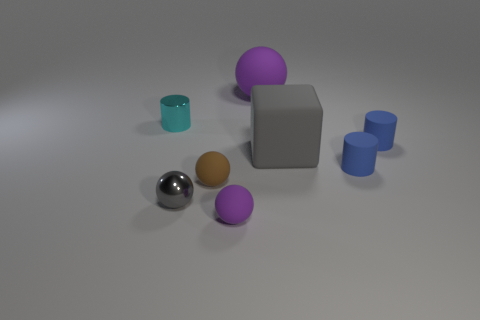Do the small purple thing and the cyan metal object have the same shape?
Ensure brevity in your answer.  No. There is a cylinder that is behind the rubber cylinder behind the gray thing behind the brown rubber object; what is its color?
Keep it short and to the point. Cyan. There is a gray object that is right of the tiny gray thing; what is its shape?
Provide a succinct answer. Cube. What number of things are either gray cubes or cylinders left of the big gray rubber thing?
Provide a succinct answer. 2. Are the cyan cylinder and the gray block made of the same material?
Your response must be concise. No. Are there the same number of brown rubber things that are in front of the tiny gray shiny sphere and tiny cyan things that are in front of the large gray block?
Offer a terse response. Yes. There is a brown rubber sphere; how many large matte balls are left of it?
Ensure brevity in your answer.  0. What number of things are small shiny cylinders or rubber blocks?
Your answer should be very brief. 2. How many brown matte objects have the same size as the cyan thing?
Your answer should be compact. 1. There is a big thing that is on the right side of the matte ball that is right of the tiny purple rubber thing; what is its shape?
Give a very brief answer. Cube. 